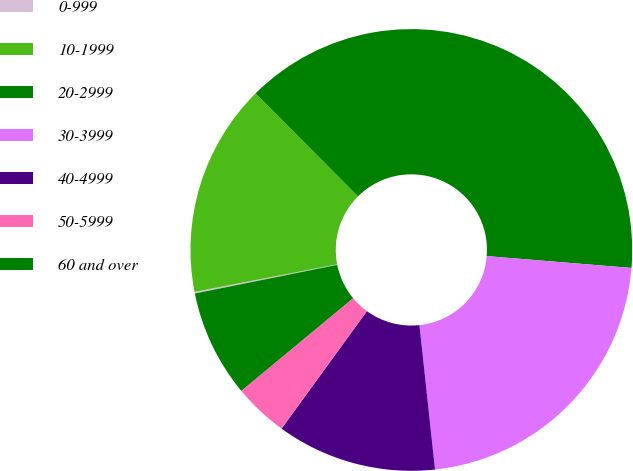Convert chart. <chart><loc_0><loc_0><loc_500><loc_500><pie_chart><fcel>0-999<fcel>10-1999<fcel>20-2999<fcel>30-3999<fcel>40-4999<fcel>50-5999<fcel>60 and over<nl><fcel>0.12%<fcel>15.58%<fcel>38.76%<fcel>21.99%<fcel>11.71%<fcel>3.99%<fcel>7.85%<nl></chart> 